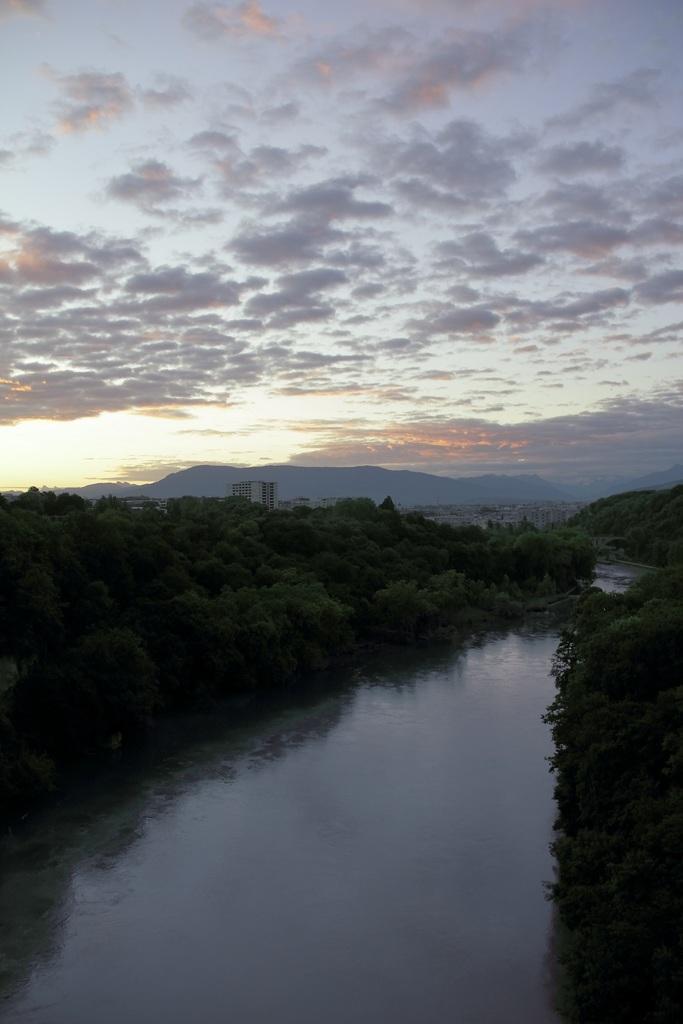Please provide a concise description of this image. In this picture there is a small water lake. On both the side there are many trees. In the background there is a mountain and clear blue sky. 